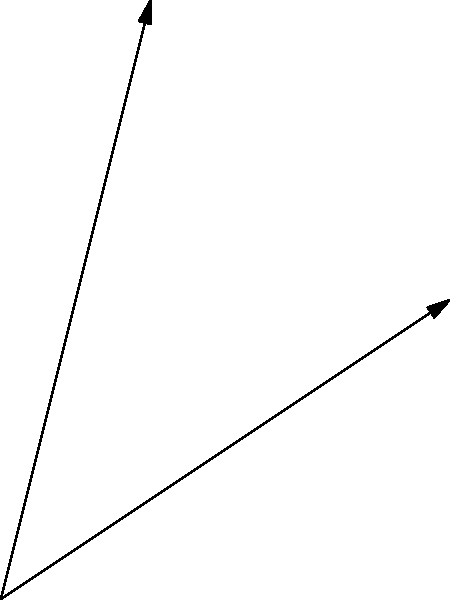In a freedom-focused story, you want to combine the themes of "Freedom" and "Human Rights" to create a powerful narrative. If the vector representing "Freedom" is $\vec{a} = 3\hat{i} + 2\hat{j}$ and the vector for "Human Rights" is $\vec{b} = \hat{i} + 4\hat{j}$, what is the resultant vector $\vec{r}$ that represents the combined impact of these themes in your story? To find the resultant vector when combining different literary themes, we can use vector addition. Here's how to solve this step-by-step:

1. We have two vectors:
   $\vec{a} = 3\hat{i} + 2\hat{j}$ (Freedom)
   $\vec{b} = \hat{i} + 4\hat{j}$ (Human Rights)

2. To find the resultant vector $\vec{r}$, we add these vectors:
   $\vec{r} = \vec{a} + \vec{b}$

3. Add the components:
   $\vec{r} = (3\hat{i} + 2\hat{j}) + (\hat{i} + 4\hat{j})$

4. Combine like terms:
   $\vec{r} = (3+1)\hat{i} + (2+4)\hat{j}$

5. Simplify:
   $\vec{r} = 4\hat{i} + 6\hat{j}$

This resultant vector represents the combined impact of the "Freedom" and "Human Rights" themes in your story, creating a more powerful and multifaceted narrative.
Answer: $4\hat{i} + 6\hat{j}$ 